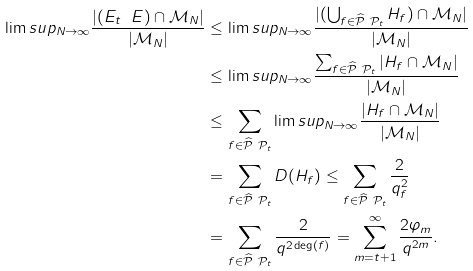<formula> <loc_0><loc_0><loc_500><loc_500>\lim s u p _ { N \rightarrow \infty } \frac { | ( E _ { t } \ E ) \cap \mathcal { M } _ { N } | } { | \mathcal { M } _ { N } | } & \leq \lim s u p _ { N \rightarrow \infty } { \frac { | ( \bigcup _ { f \in \widehat { \mathcal { P } } \ \mathcal { P } _ { t } } H _ { f } ) \cap \mathcal { M } _ { N } | } { | \mathcal { M } _ { N } | } } \\ & \leq \lim s u p _ { N \rightarrow \infty } { \frac { \sum _ { f \in \widehat { \mathcal { P } } \ \mathcal { P } _ { t } } | H _ { f } \cap \mathcal { M } _ { N } | } { | \mathcal { M } _ { N } | } } \\ & \leq \sum _ { f \in \widehat { \mathcal { P } } \ \mathcal { P } _ { t } } \lim s u p _ { N \rightarrow \infty } { \frac { | H _ { f } \cap \mathcal { M } _ { N } | } { | \mathcal { M } _ { N } | } } \\ & = \sum _ { f \in \widehat { \mathcal { P } } \ \mathcal { P } _ { t } } D ( H _ { f } ) \leq \sum _ { f \in \widehat { \mathcal { P } } \ \mathcal { P } _ { t } } \frac { 2 } { q _ { f } ^ { 2 } } \\ & = \sum _ { f \in \widehat { \mathcal { P } } \ \mathcal { P } _ { t } } \frac { 2 } { q ^ { 2 \deg ( f ) } } = \sum _ { m = t + 1 } ^ { \infty } \frac { 2 \varphi _ { m } } { q ^ { 2 m } } .</formula> 